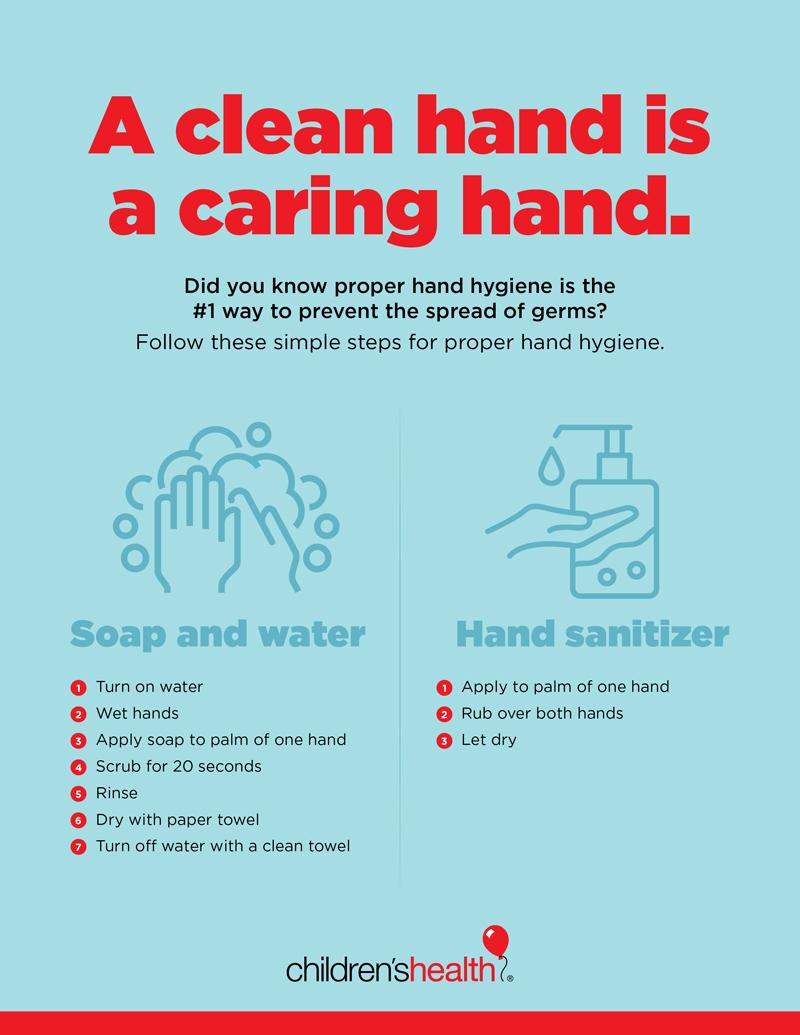Mention a couple of crucial points in this snapshot. To maintain good hand hygiene, two methods that can be employed are the use of soap and water, and the application of hand sanitizer. 